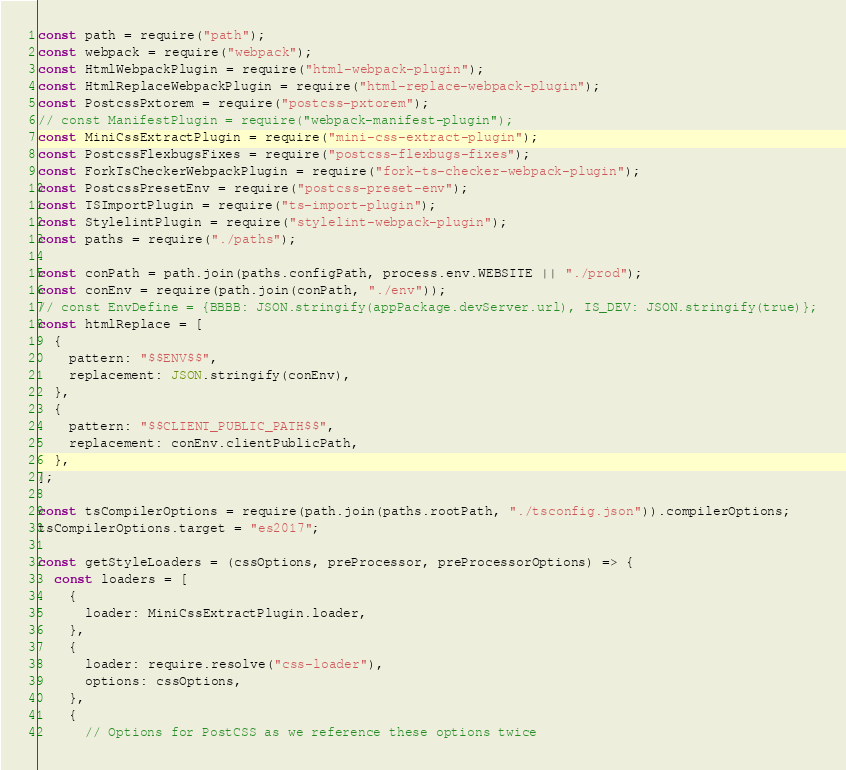<code> <loc_0><loc_0><loc_500><loc_500><_JavaScript_>const path = require("path");
const webpack = require("webpack");
const HtmlWebpackPlugin = require("html-webpack-plugin");
const HtmlReplaceWebpackPlugin = require("html-replace-webpack-plugin");
const PostcssPxtorem = require("postcss-pxtorem");
// const ManifestPlugin = require("webpack-manifest-plugin");
const MiniCssExtractPlugin = require("mini-css-extract-plugin");
const PostcssFlexbugsFixes = require("postcss-flexbugs-fixes");
const ForkTsCheckerWebpackPlugin = require("fork-ts-checker-webpack-plugin");
const PostcssPresetEnv = require("postcss-preset-env");
const TSImportPlugin = require("ts-import-plugin");
const StylelintPlugin = require("stylelint-webpack-plugin");
const paths = require("./paths");

const conPath = path.join(paths.configPath, process.env.WEBSITE || "./prod");
const conEnv = require(path.join(conPath, "./env"));
// const EnvDefine = {BBBB: JSON.stringify(appPackage.devServer.url), IS_DEV: JSON.stringify(true)};
const htmlReplace = [
  {
    pattern: "$$ENV$$",
    replacement: JSON.stringify(conEnv),
  },
  {
    pattern: "$$CLIENT_PUBLIC_PATH$$",
    replacement: conEnv.clientPublicPath,
  },
];

const tsCompilerOptions = require(path.join(paths.rootPath, "./tsconfig.json")).compilerOptions;
tsCompilerOptions.target = "es2017";

const getStyleLoaders = (cssOptions, preProcessor, preProcessorOptions) => {
  const loaders = [
    {
      loader: MiniCssExtractPlugin.loader,
    },
    {
      loader: require.resolve("css-loader"),
      options: cssOptions,
    },
    {
      // Options for PostCSS as we reference these options twice</code> 